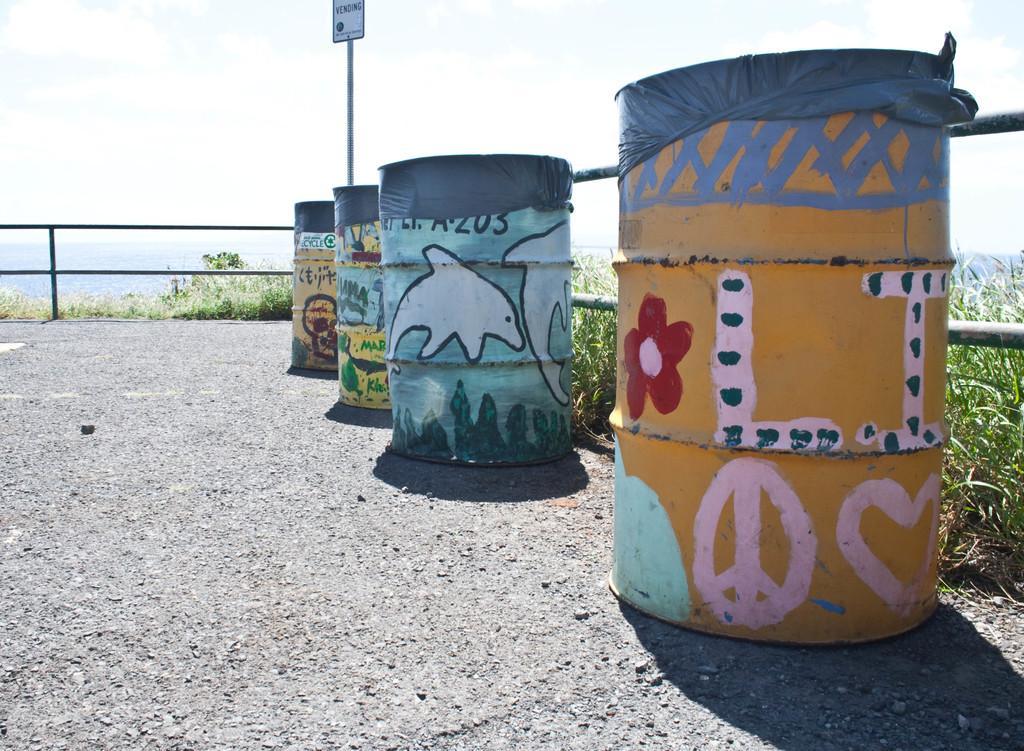How would you summarize this image in a sentence or two? In this picture we can see four painted barrels on the ground with covers on it, name board attached to a pole, fences, plants and in the background we can see the sky with clouds. 